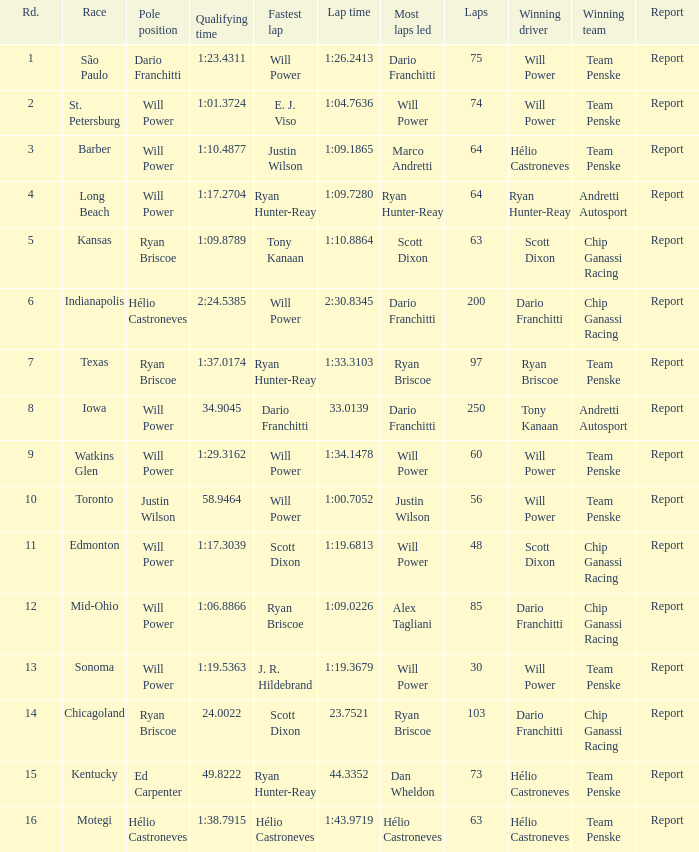What is the report for races where Will Power had both pole position and fastest lap? Report. 